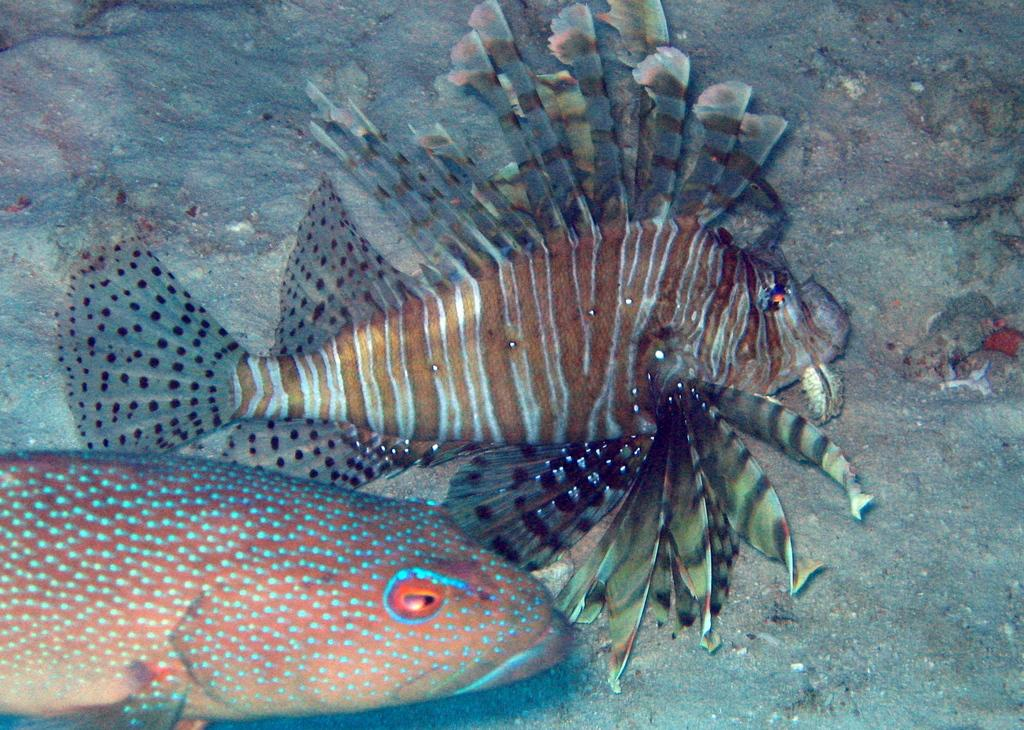What type of animals can be seen in the image? There are fishes in the image. What type of berry is being served by the secretary in the image? There is no secretary or berry present in the image; it only features fishes. 